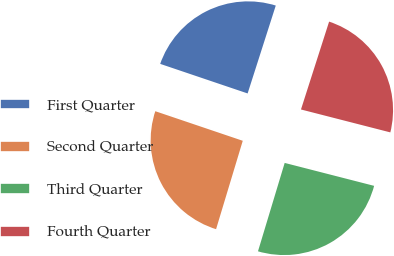Convert chart to OTSL. <chart><loc_0><loc_0><loc_500><loc_500><pie_chart><fcel>First Quarter<fcel>Second Quarter<fcel>Third Quarter<fcel>Fourth Quarter<nl><fcel>24.74%<fcel>25.52%<fcel>25.67%<fcel>24.06%<nl></chart> 